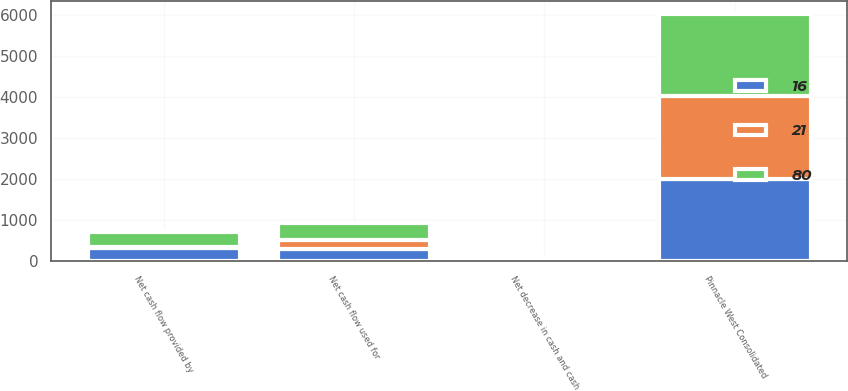<chart> <loc_0><loc_0><loc_500><loc_500><stacked_bar_chart><ecel><fcel>Pinnacle West Consolidated<fcel>Net cash flow provided by<fcel>Net cash flow used for<fcel>Net decrease in cash and cash<nl><fcel>16<fcel>2012<fcel>319<fcel>305<fcel>7<nl><fcel>80<fcel>2011<fcel>374<fcel>420<fcel>77<nl><fcel>21<fcel>2010<fcel>31<fcel>209<fcel>35<nl></chart> 